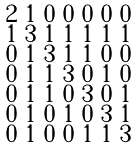Convert formula to latex. <formula><loc_0><loc_0><loc_500><loc_500>\begin{smallmatrix} 2 & 1 & 0 & 0 & 0 & 0 & 0 \\ 1 & 3 & 1 & 1 & 1 & 1 & 1 \\ 0 & 1 & 3 & 1 & 1 & 0 & 0 \\ 0 & 1 & 1 & 3 & 0 & 1 & 0 \\ 0 & 1 & 1 & 0 & 3 & 0 & 1 \\ 0 & 1 & 0 & 1 & 0 & 3 & 1 \\ 0 & 1 & 0 & 0 & 1 & 1 & 3 \end{smallmatrix}</formula> 